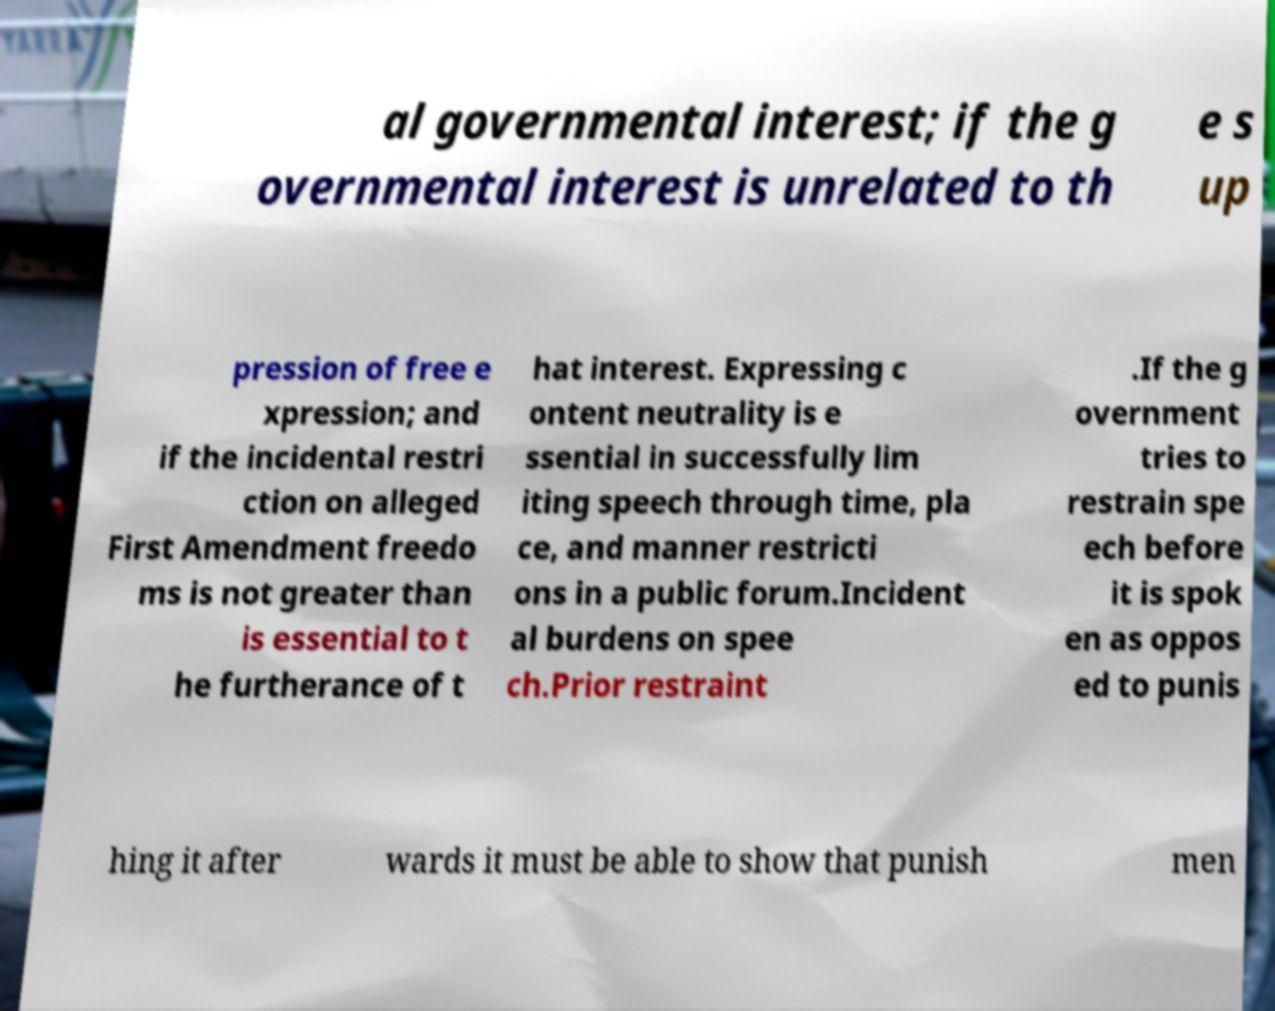Please read and relay the text visible in this image. What does it say? al governmental interest; if the g overnmental interest is unrelated to th e s up pression of free e xpression; and if the incidental restri ction on alleged First Amendment freedo ms is not greater than is essential to t he furtherance of t hat interest. Expressing c ontent neutrality is e ssential in successfully lim iting speech through time, pla ce, and manner restricti ons in a public forum.Incident al burdens on spee ch.Prior restraint .If the g overnment tries to restrain spe ech before it is spok en as oppos ed to punis hing it after wards it must be able to show that punish men 